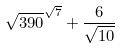Convert formula to latex. <formula><loc_0><loc_0><loc_500><loc_500>\sqrt { 3 9 0 } ^ { \sqrt { 7 } } + \frac { 6 } { \sqrt { 1 0 } }</formula> 